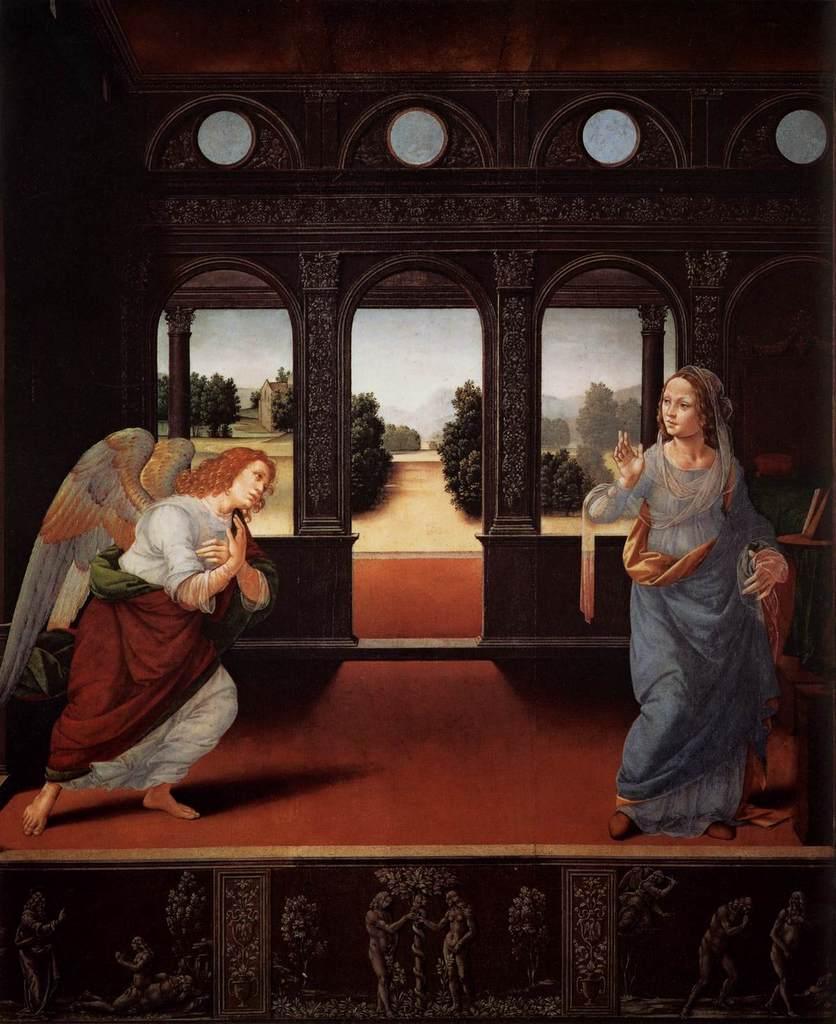Describe this image in one or two sentences. In this image there is a painting of two ladies standing on the stage, one of them is wearing wings on his shoulder. In the background there is a wall and trees. 